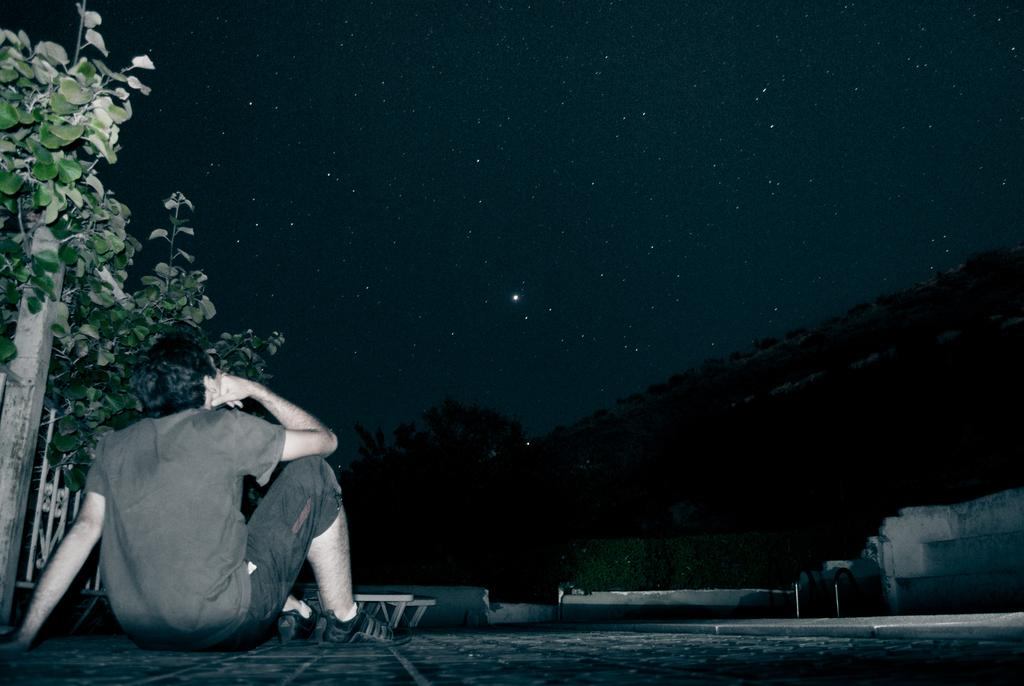What is the man in the image doing? The man is sitting on the floor in the image. What is located beside the man? There is a plant beside the man. What can be seen in the background of the image? There is a mountain and the sky visible in the background of the image. What celestial objects can be seen in the sky? Stars are present in the sky. What type of stocking is the creature wearing on its front legs in the image? There is no creature present in the image, and therefore no stockings or legs can be observed. 